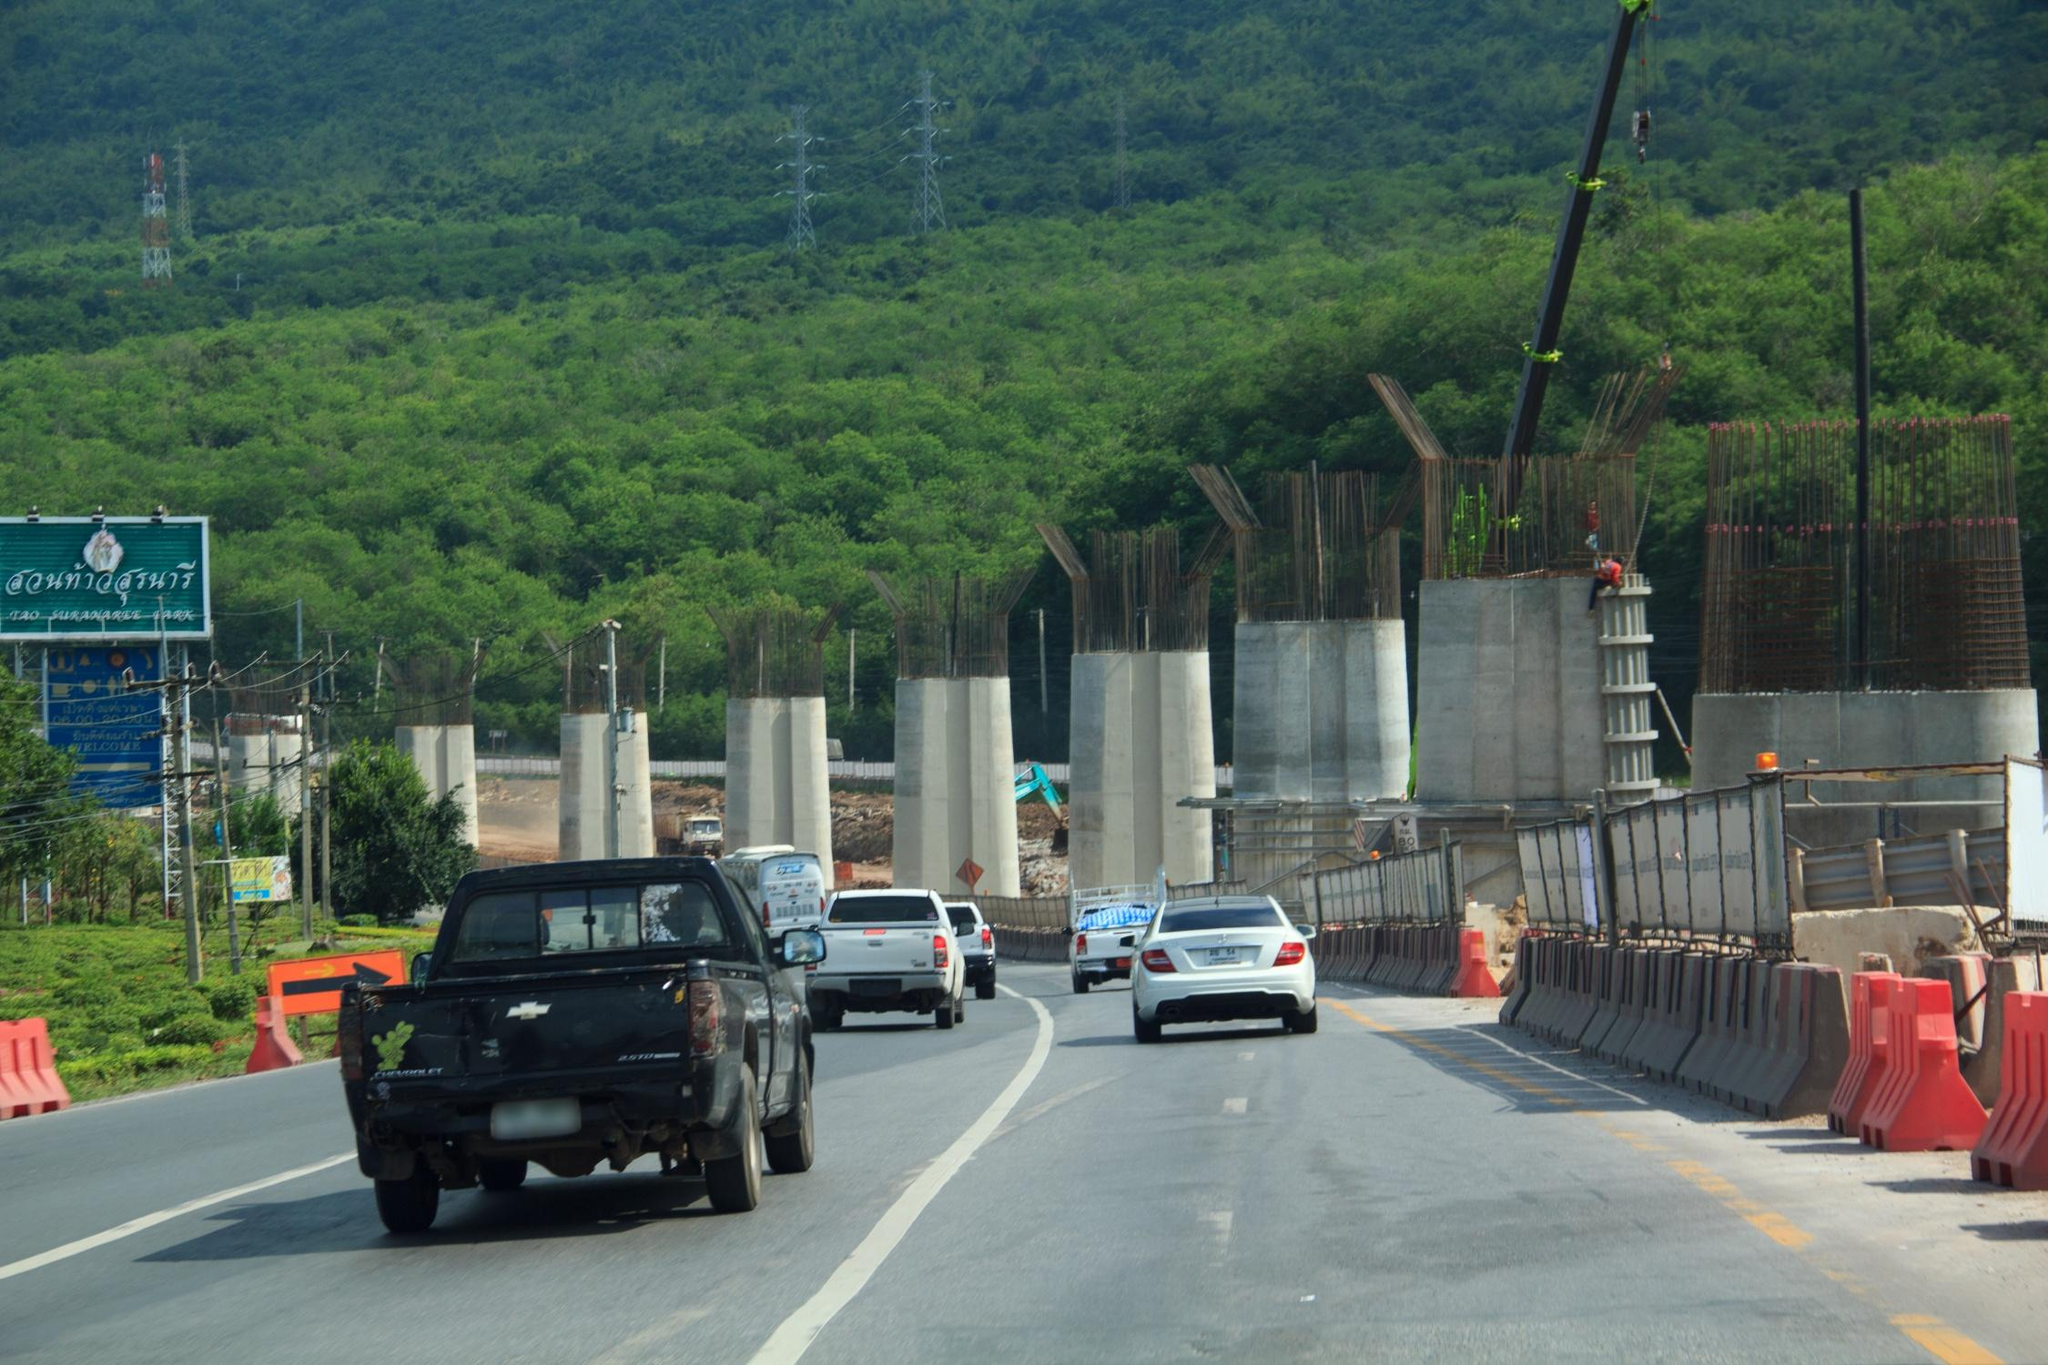As seen in the image, what would happen if a giant mythical creature appears in the scene? Imagine a colossal, mythical creature suddenly emerging amidst the construction site! The construction workers would pause in awe as a massive dragon with glimmering scales, spanning multiple hues of emerald and gold, gracefully touches down. Its wings create gusts of wind, momentarily halting all activities. The creature's appearance could be a harbinger of a fantastical age, where humans and mythical beings coexist. The dragon, with intelligence far surpassing human understanding, might offer to assist in the construction, using its colossal strength to transport large sections of the highway effortlessly. This unexpected alliance could accelerate the construction process, resulting in not only a technologically advanced highway but one imbued with elements of magic. As the dragon departs, leaving behind a pathway enveloped in enchantment, legends would be born and the area would evolve into a historical landmark, drawing visitors from all over the world to witness the site where reality once merged with myth. 